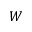Convert formula to latex. <formula><loc_0><loc_0><loc_500><loc_500>W</formula> 